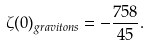<formula> <loc_0><loc_0><loc_500><loc_500>\zeta ( 0 ) _ { g r a v i t o n s } = - \frac { 7 5 8 } { 4 5 } .</formula> 